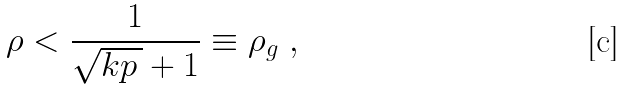<formula> <loc_0><loc_0><loc_500><loc_500>\rho < \frac { 1 } { \sqrt { k p \, } + 1 } \equiv \rho _ { g } \ ,</formula> 